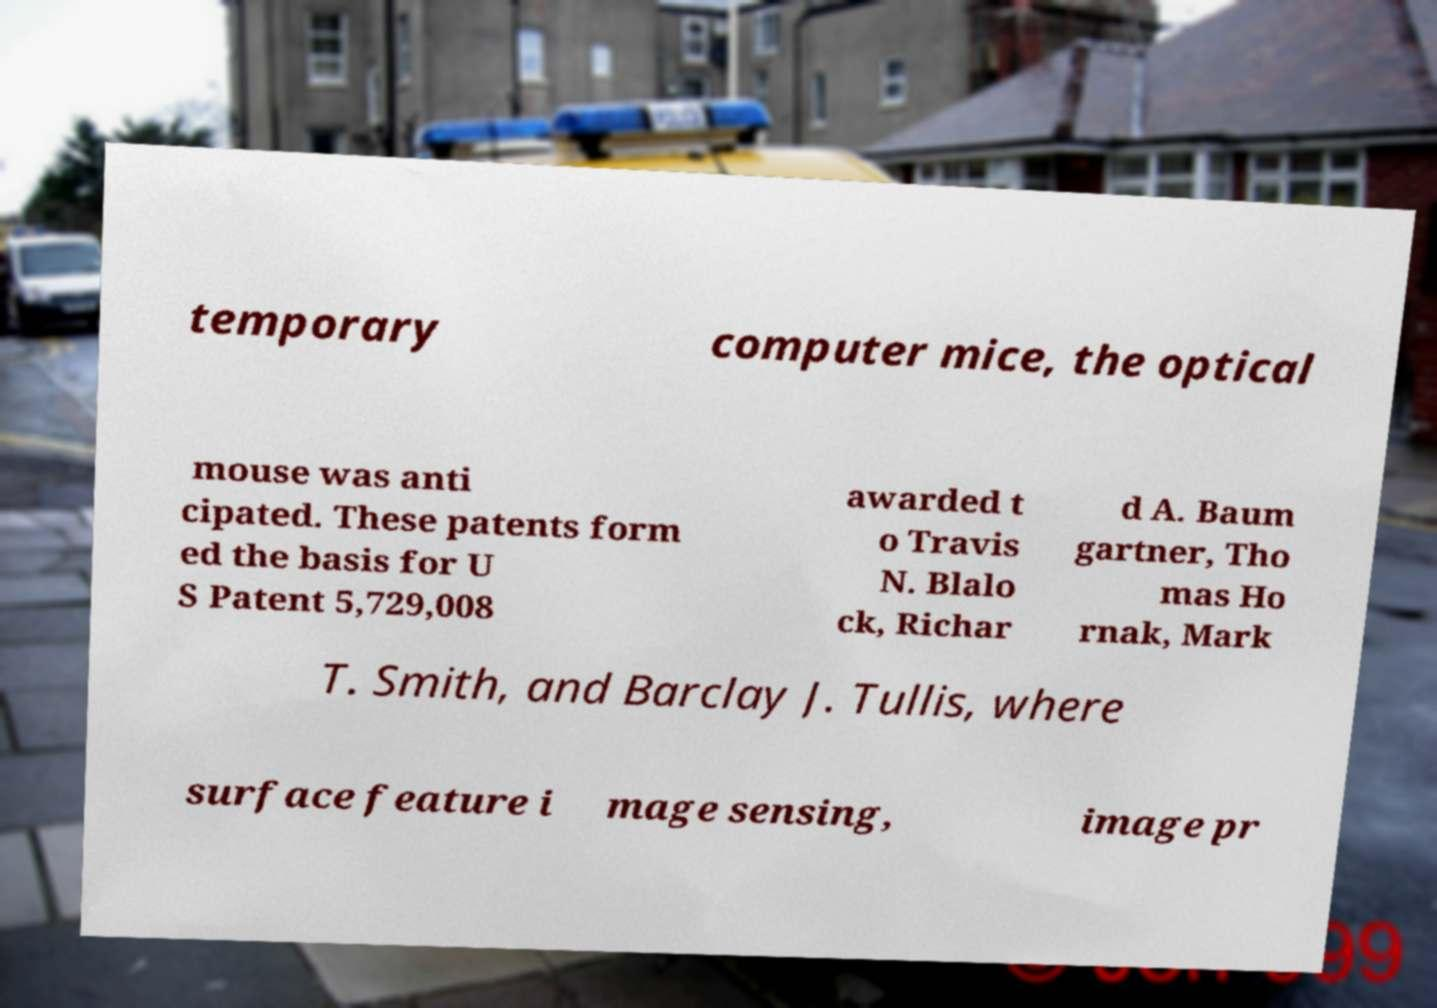There's text embedded in this image that I need extracted. Can you transcribe it verbatim? temporary computer mice, the optical mouse was anti cipated. These patents form ed the basis for U S Patent 5,729,008 awarded t o Travis N. Blalo ck, Richar d A. Baum gartner, Tho mas Ho rnak, Mark T. Smith, and Barclay J. Tullis, where surface feature i mage sensing, image pr 